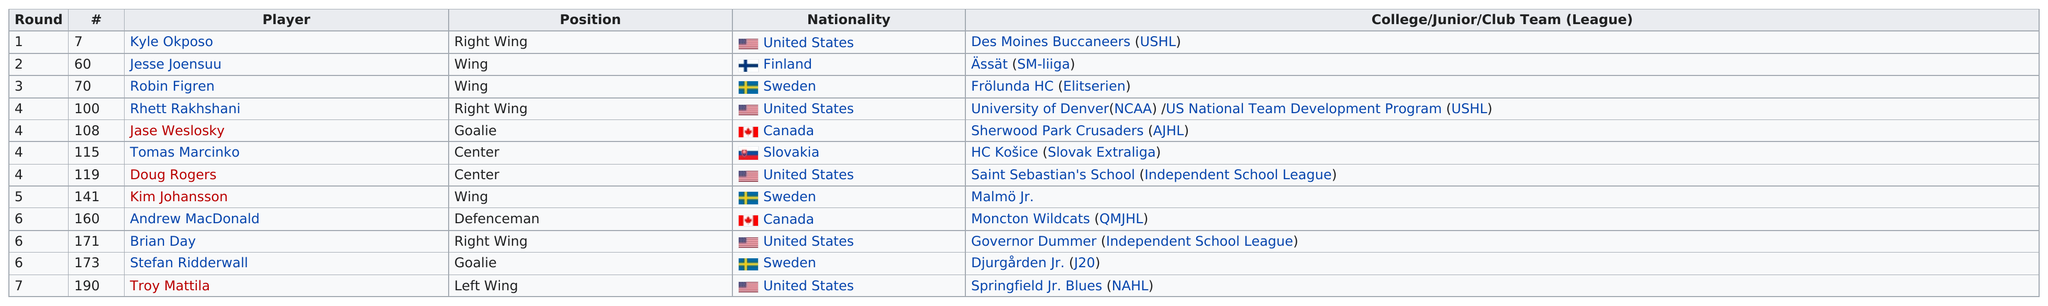List a handful of essential elements in this visual. Five players were drafted by the 2006-2007 Islanders from the United States. The Islanders drafted two centers in the 2006 NHL Entry Draft. In 2006, the Islanders made a total of 12 selections in the NHL entry draft. The New York Islanders drafted two goalies. Jesse Joensuu was the only Finnish player selected. 